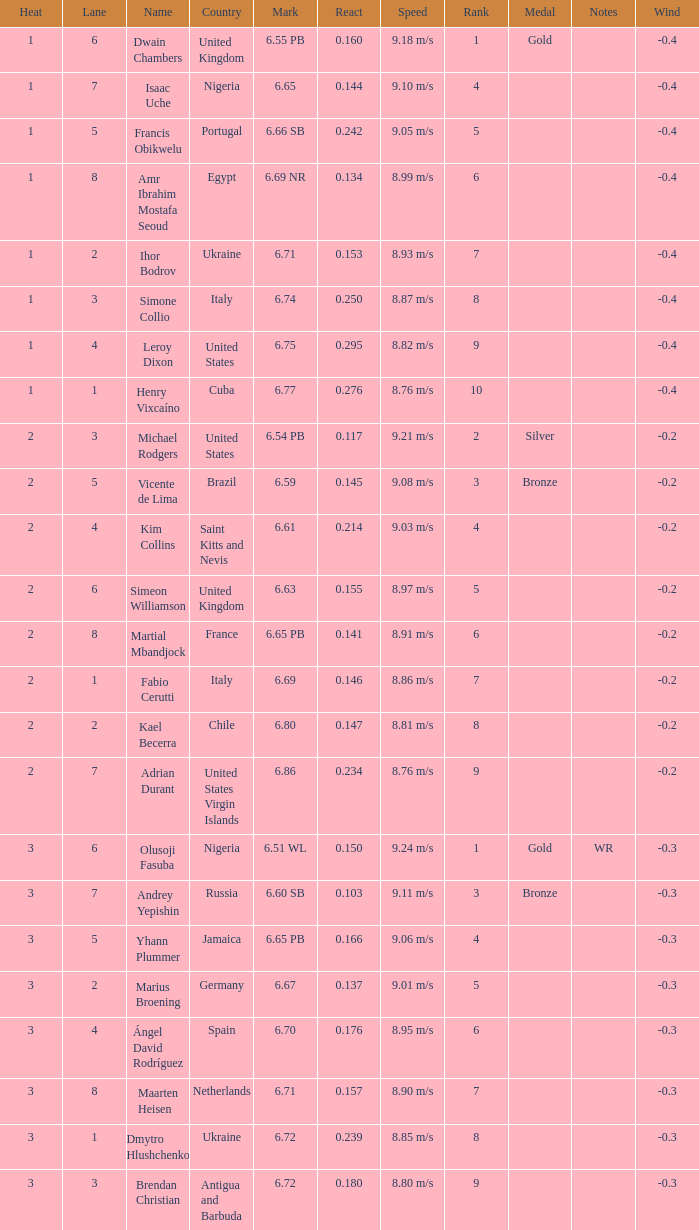What is Country, when Lane is 5, and when React is greater than 0.166? Portugal. 